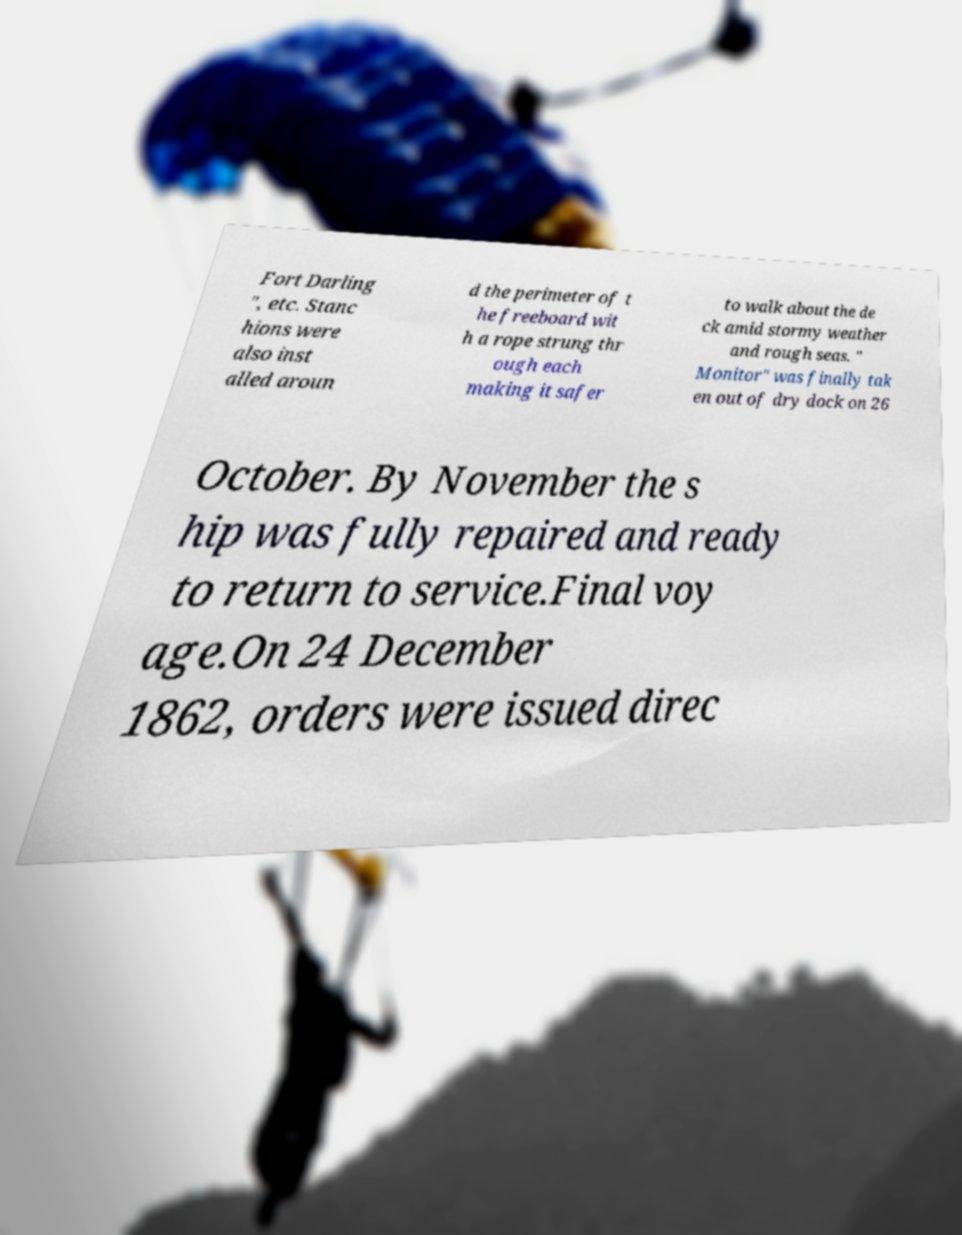There's text embedded in this image that I need extracted. Can you transcribe it verbatim? Fort Darling ", etc. Stanc hions were also inst alled aroun d the perimeter of t he freeboard wit h a rope strung thr ough each making it safer to walk about the de ck amid stormy weather and rough seas. " Monitor" was finally tak en out of dry dock on 26 October. By November the s hip was fully repaired and ready to return to service.Final voy age.On 24 December 1862, orders were issued direc 